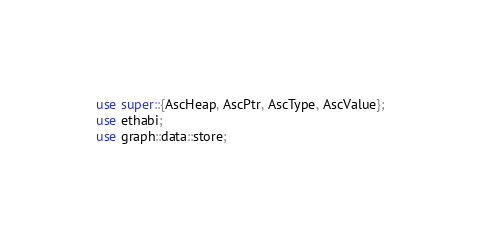<code> <loc_0><loc_0><loc_500><loc_500><_Rust_>use super::{AscHeap, AscPtr, AscType, AscValue};
use ethabi;
use graph::data::store;</code> 